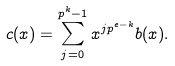Convert formula to latex. <formula><loc_0><loc_0><loc_500><loc_500>c ( x ) = \sum _ { j = 0 } ^ { p ^ { k } - 1 } x ^ { j p ^ { e - k } } b ( x ) .</formula> 